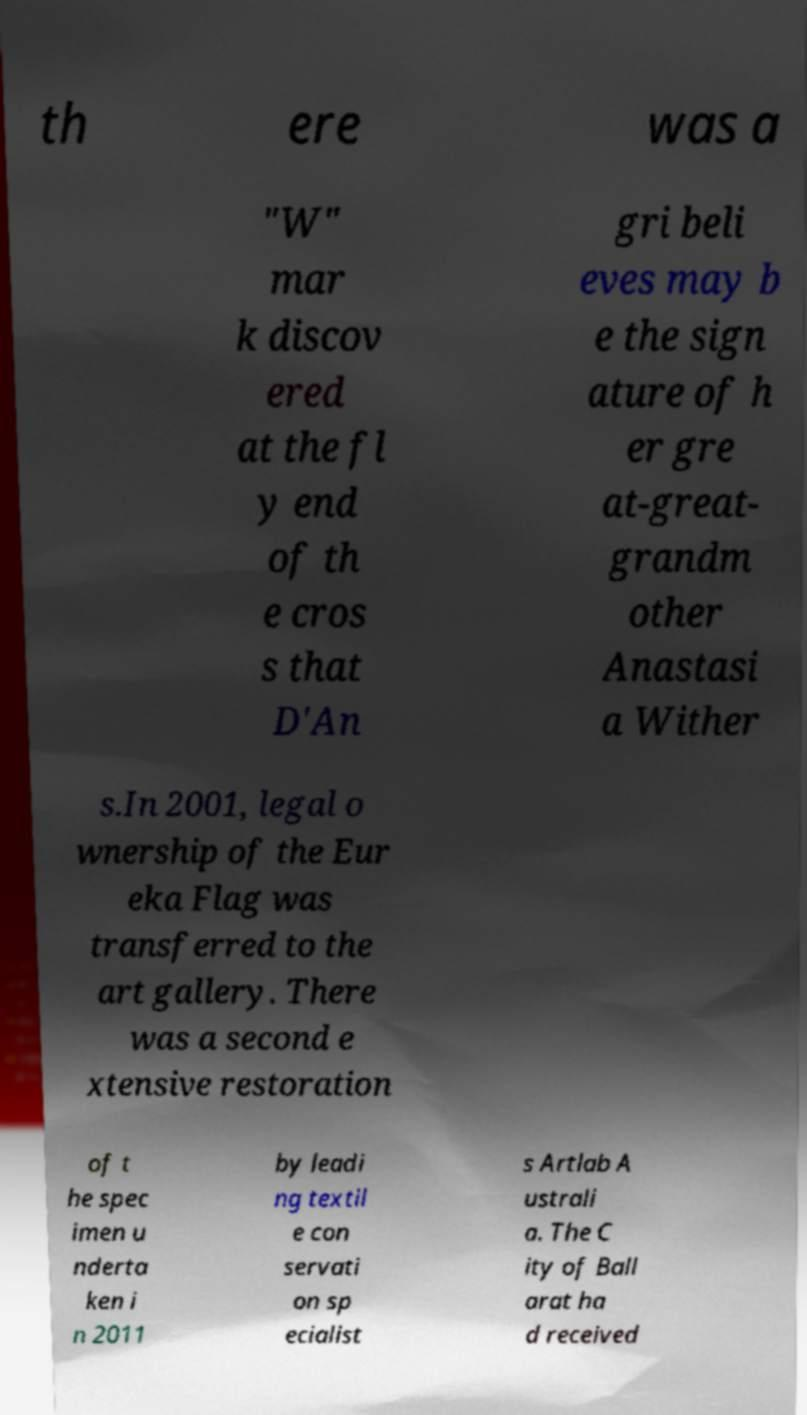Can you accurately transcribe the text from the provided image for me? th ere was a "W" mar k discov ered at the fl y end of th e cros s that D'An gri beli eves may b e the sign ature of h er gre at-great- grandm other Anastasi a Wither s.In 2001, legal o wnership of the Eur eka Flag was transferred to the art gallery. There was a second e xtensive restoration of t he spec imen u nderta ken i n 2011 by leadi ng textil e con servati on sp ecialist s Artlab A ustrali a. The C ity of Ball arat ha d received 